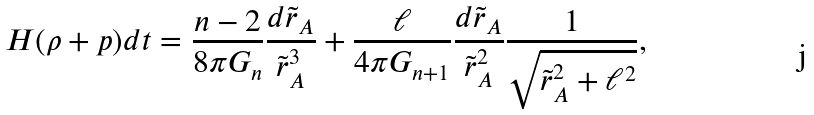Convert formula to latex. <formula><loc_0><loc_0><loc_500><loc_500>H ( \rho + p ) d t = \frac { n - 2 } { 8 \pi G _ { n } } \frac { d \tilde { r } _ { A } } { { \tilde { r } _ { A } } ^ { 3 } } + \frac { \ell } { 4 \pi G _ { n + 1 } } \frac { d \tilde { r } _ { A } } { { \tilde { r } _ { A } } ^ { 2 } } \frac { 1 } { \sqrt { { \tilde { r } _ { A } } ^ { 2 } + \ell ^ { 2 } } } ,</formula> 